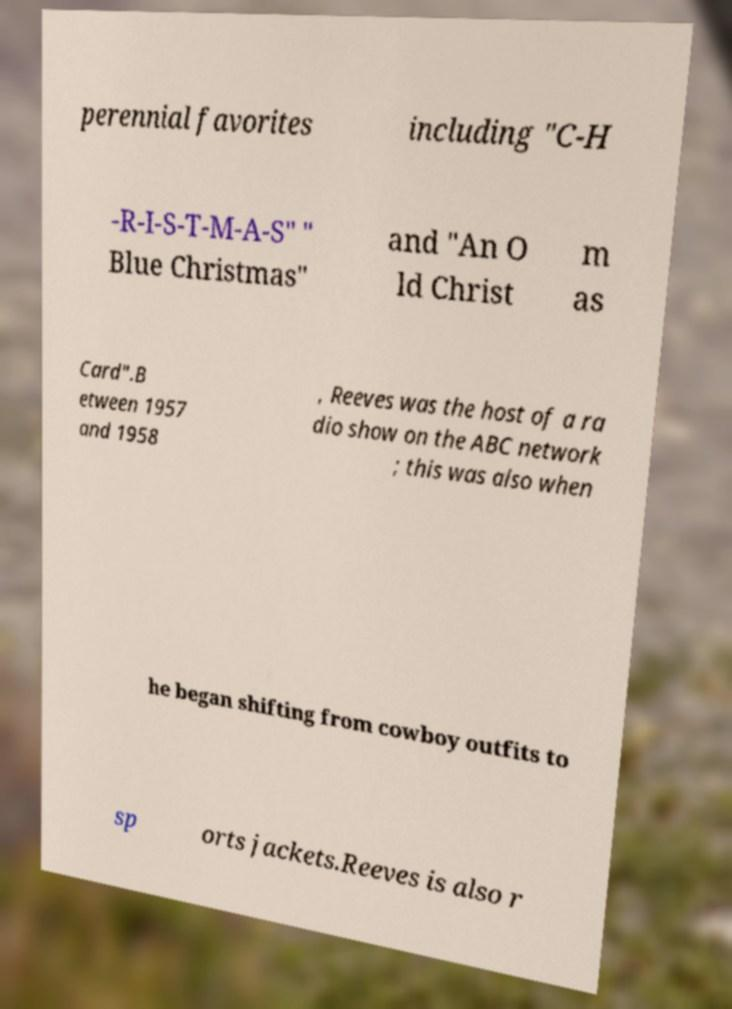Can you read and provide the text displayed in the image?This photo seems to have some interesting text. Can you extract and type it out for me? perennial favorites including "C-H -R-I-S-T-M-A-S" " Blue Christmas" and "An O ld Christ m as Card".B etween 1957 and 1958 , Reeves was the host of a ra dio show on the ABC network ; this was also when he began shifting from cowboy outfits to sp orts jackets.Reeves is also r 